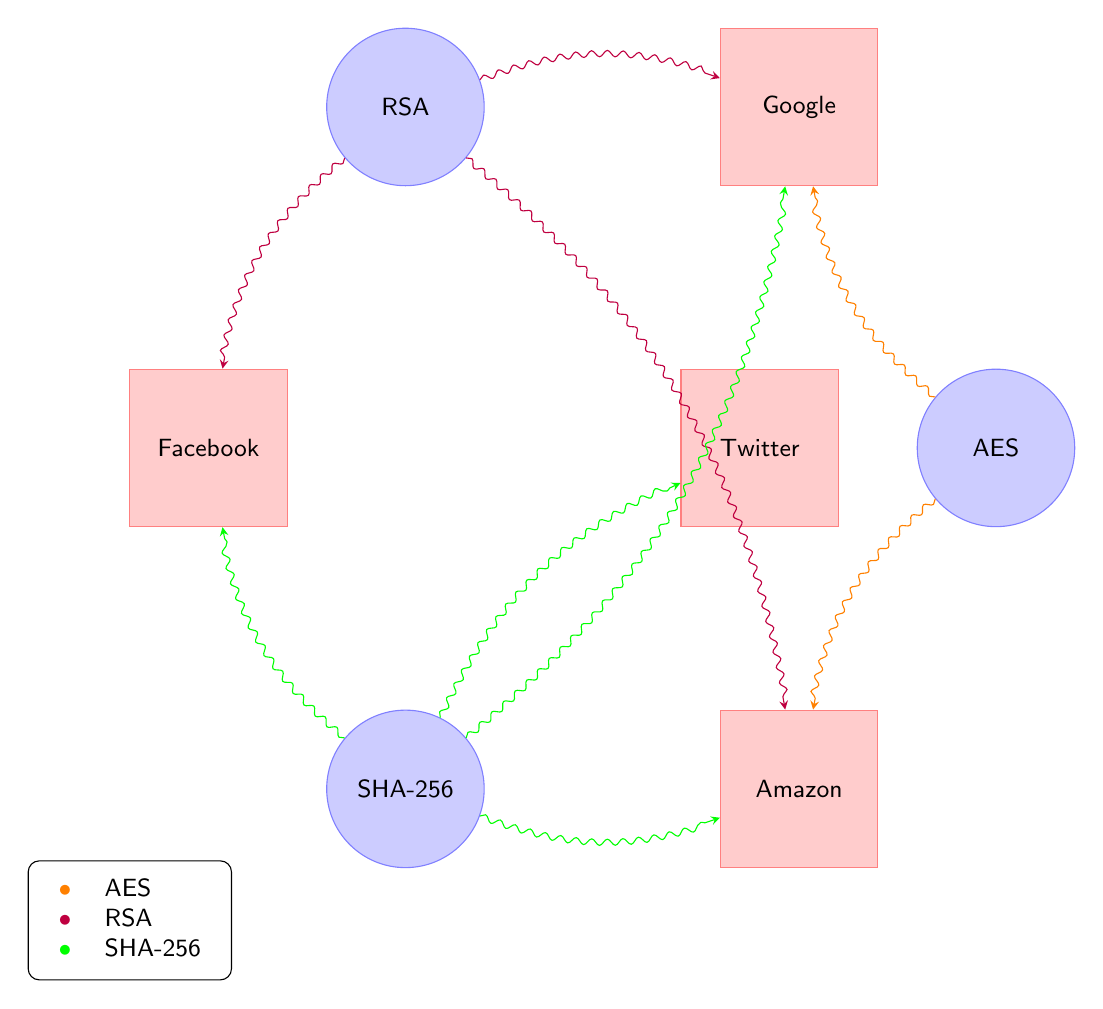What is the total number of nodes in the diagram? The diagram consists of three cryptographic algorithms (AES, RSA, SHA-256) and four websites (Google, Facebook, Amazon, Twitter), adding up to a total of seven nodes.
Answer: 7 Which website is linked to both AES and SHA-256? By examining the connections, Amazon is linked to both AES and SHA-256, as indicated by the directed links from these algorithms to Amazon.
Answer: Amazon How many algorithms are connected to Google? The algorithm nodes connected to Google are AES, RSA, and SHA-256, which together make three connections.
Answer: 3 What is the relationship between RSA and Facebook? The diagram shows a direct link from the RSA algorithm to Facebook, indicating that RSA is implemented by Facebook.
Answer: Direct link Which algorithm has the most connections in the diagram? SHA-256 has four connections to websites (Google, Facebook, Amazon, Twitter), which is more than AES and RSA that have two and three respectively.
Answer: SHA-256 How many total connections are shown in this diagram? The connections include: AES to Google, AES to Amazon, RSA to Google, RSA to Facebook, RSA to Amazon, SHA-256 to Google, SHA-256 to Facebook, SHA-256 to Amazon, and SHA-256 to Twitter, totaling nine distinct connections.
Answer: 9 Which algorithm is not linked to Twitter? Upon review,  AES and RSA do not have any direct links to Twitter, while SHA-256 does connect to Twitter. Thus, both AES and RSA are not linked to Twitter.
Answer: AES and RSA Which website implements both SHA-256 and RSA? By examining the links, it is evident that Amazon implements both SHA-256 and RSA, as indicated by the directed links to this website from each algorithm.
Answer: Amazon 